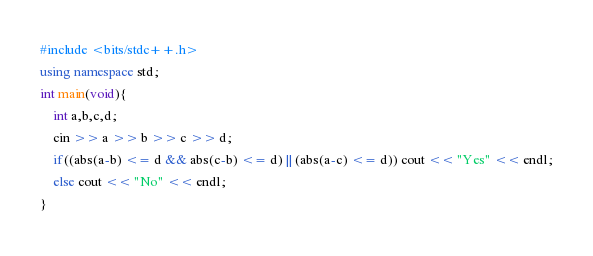Convert code to text. <code><loc_0><loc_0><loc_500><loc_500><_C++_>#include <bits/stdc++.h>
using namespace std;
int main(void){
    int a,b,c,d;
    cin >> a >> b >> c >> d;
    if((abs(a-b) <= d && abs(c-b) <= d) || (abs(a-c) <= d)) cout << "Yes" << endl;
    else cout << "No" << endl;
}</code> 